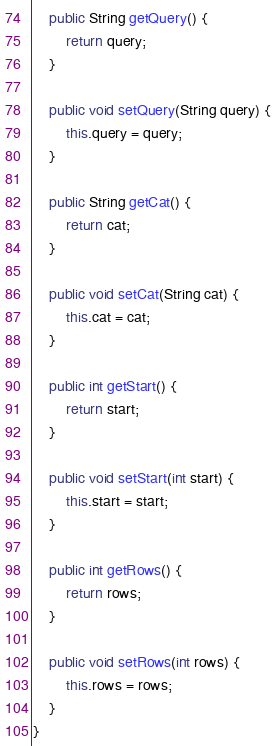Convert code to text. <code><loc_0><loc_0><loc_500><loc_500><_Java_>    public String getQuery() {
        return query;
    }

    public void setQuery(String query) {
        this.query = query;
    }

    public String getCat() {
        return cat;
    }

    public void setCat(String cat) {
        this.cat = cat;
    }

    public int getStart() {
        return start;
    }

    public void setStart(int start) {
        this.start = start;
    }

    public int getRows() {
        return rows;
    }

    public void setRows(int rows) {
        this.rows = rows;
    }
}
</code> 